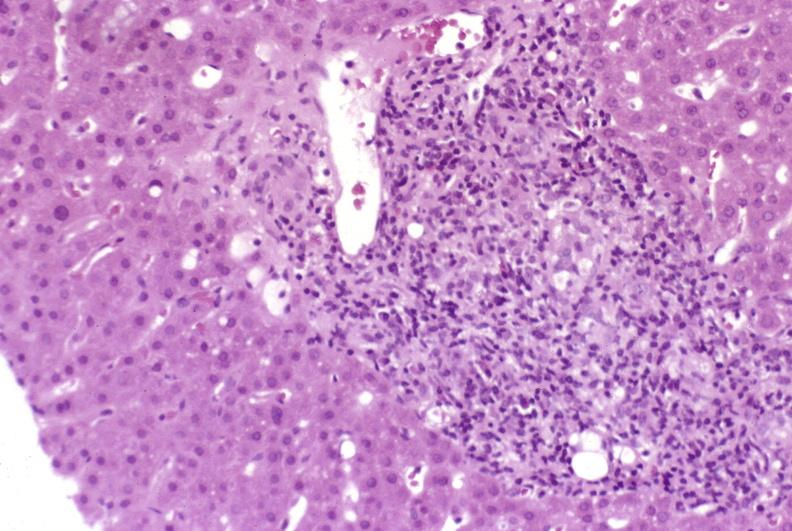s liver present?
Answer the question using a single word or phrase. Yes 